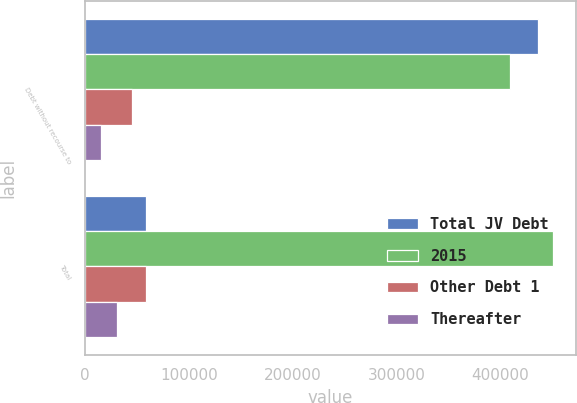Convert chart to OTSL. <chart><loc_0><loc_0><loc_500><loc_500><stacked_bar_chart><ecel><fcel>Debt without recourse to<fcel>Total<nl><fcel>Total JV Debt<fcel>435968<fcel>58438<nl><fcel>2015<fcel>409461<fcel>450457<nl><fcel>Other Debt 1<fcel>45328<fcel>58438<nl><fcel>Thereafter<fcel>15327<fcel>30327<nl></chart> 